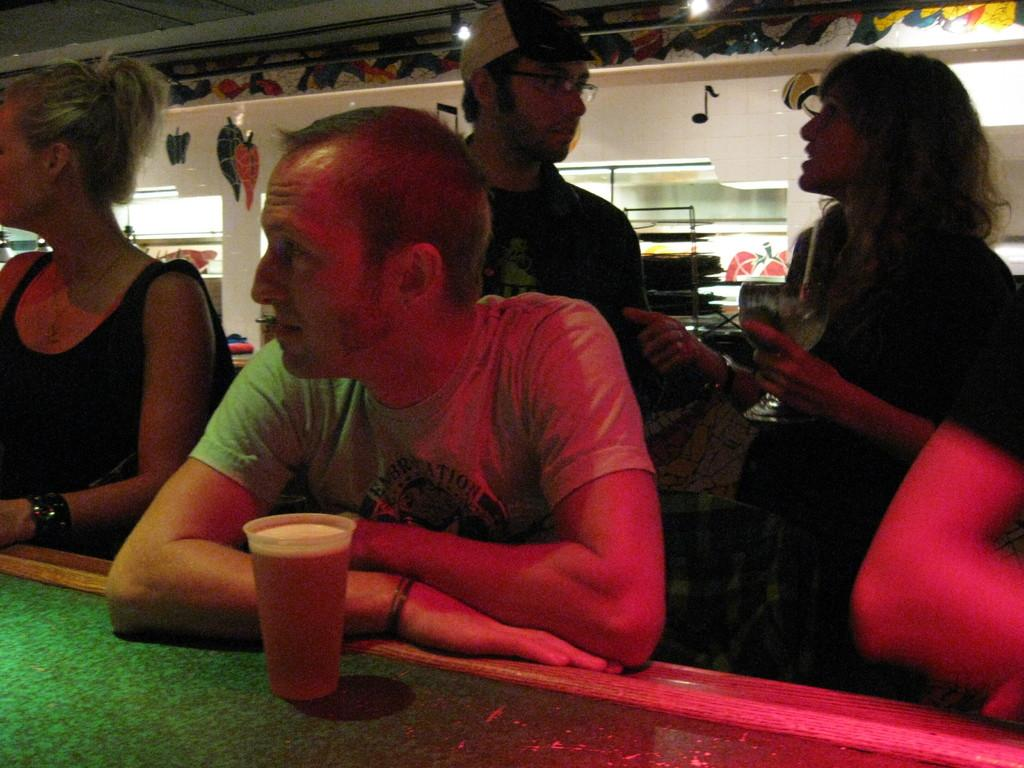How many people are present in the image? There are 3 people sitting in the image. What is the person at the center wearing? The person at the center is wearing a grey t-shirt. What object is in front of the person at the center? There is a glass in front of the person at the center. What are the two people behind the sitting person doing? The two standing people are talking to each other. What type of jellyfish can be seen swimming in the glass in front of the person at the center? There are no jellyfish present in the image; the glass is empty or contains a different substance. Can you tell me the name of the man standing behind the sitting person? The provided facts do not mention any names, so it is not possible to identify the man by name. 